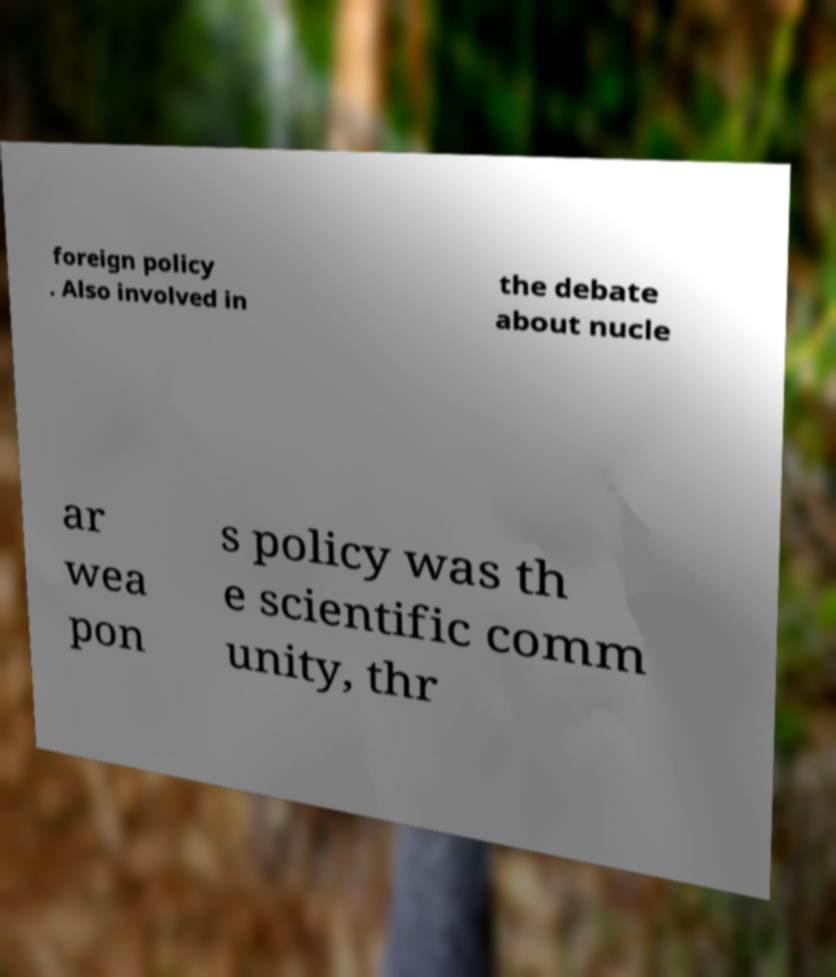Can you accurately transcribe the text from the provided image for me? foreign policy . Also involved in the debate about nucle ar wea pon s policy was th e scientific comm unity, thr 